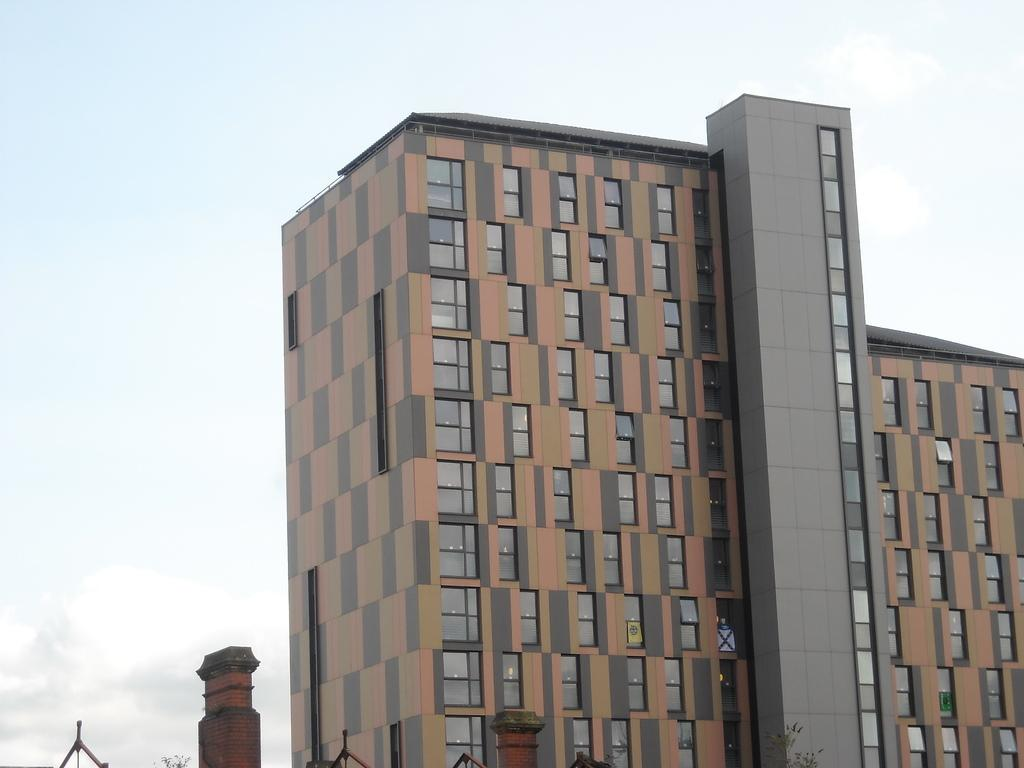What type of structure is present in the image? There is a building with windows in the image. What else can be seen in the image besides the building? There are poles and trees visible in the image. What is visible in the background of the image? The sky is visible in the background of the image. Where is the hose located in the image? There is no hose present in the image. What type of bed is visible in the image? There is no bed present in the image. 